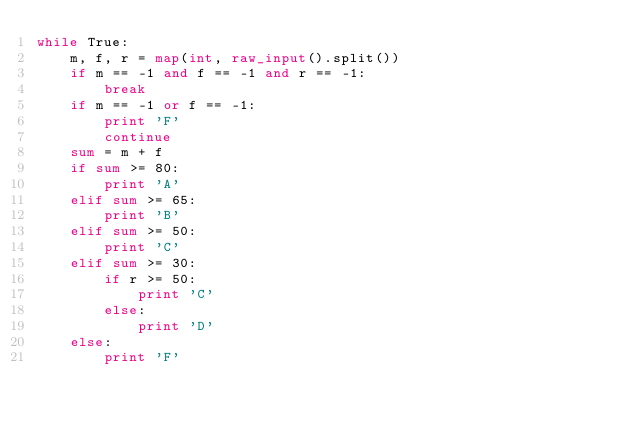Convert code to text. <code><loc_0><loc_0><loc_500><loc_500><_Python_>while True:
    m, f, r = map(int, raw_input().split())
    if m == -1 and f == -1 and r == -1:
        break
    if m == -1 or f == -1:
        print 'F'
        continue
    sum = m + f
    if sum >= 80:
        print 'A'
    elif sum >= 65:
        print 'B'
    elif sum >= 50:
        print 'C'
    elif sum >= 30:
        if r >= 50:
            print 'C'
        else:
            print 'D'
    else:
        print 'F'</code> 